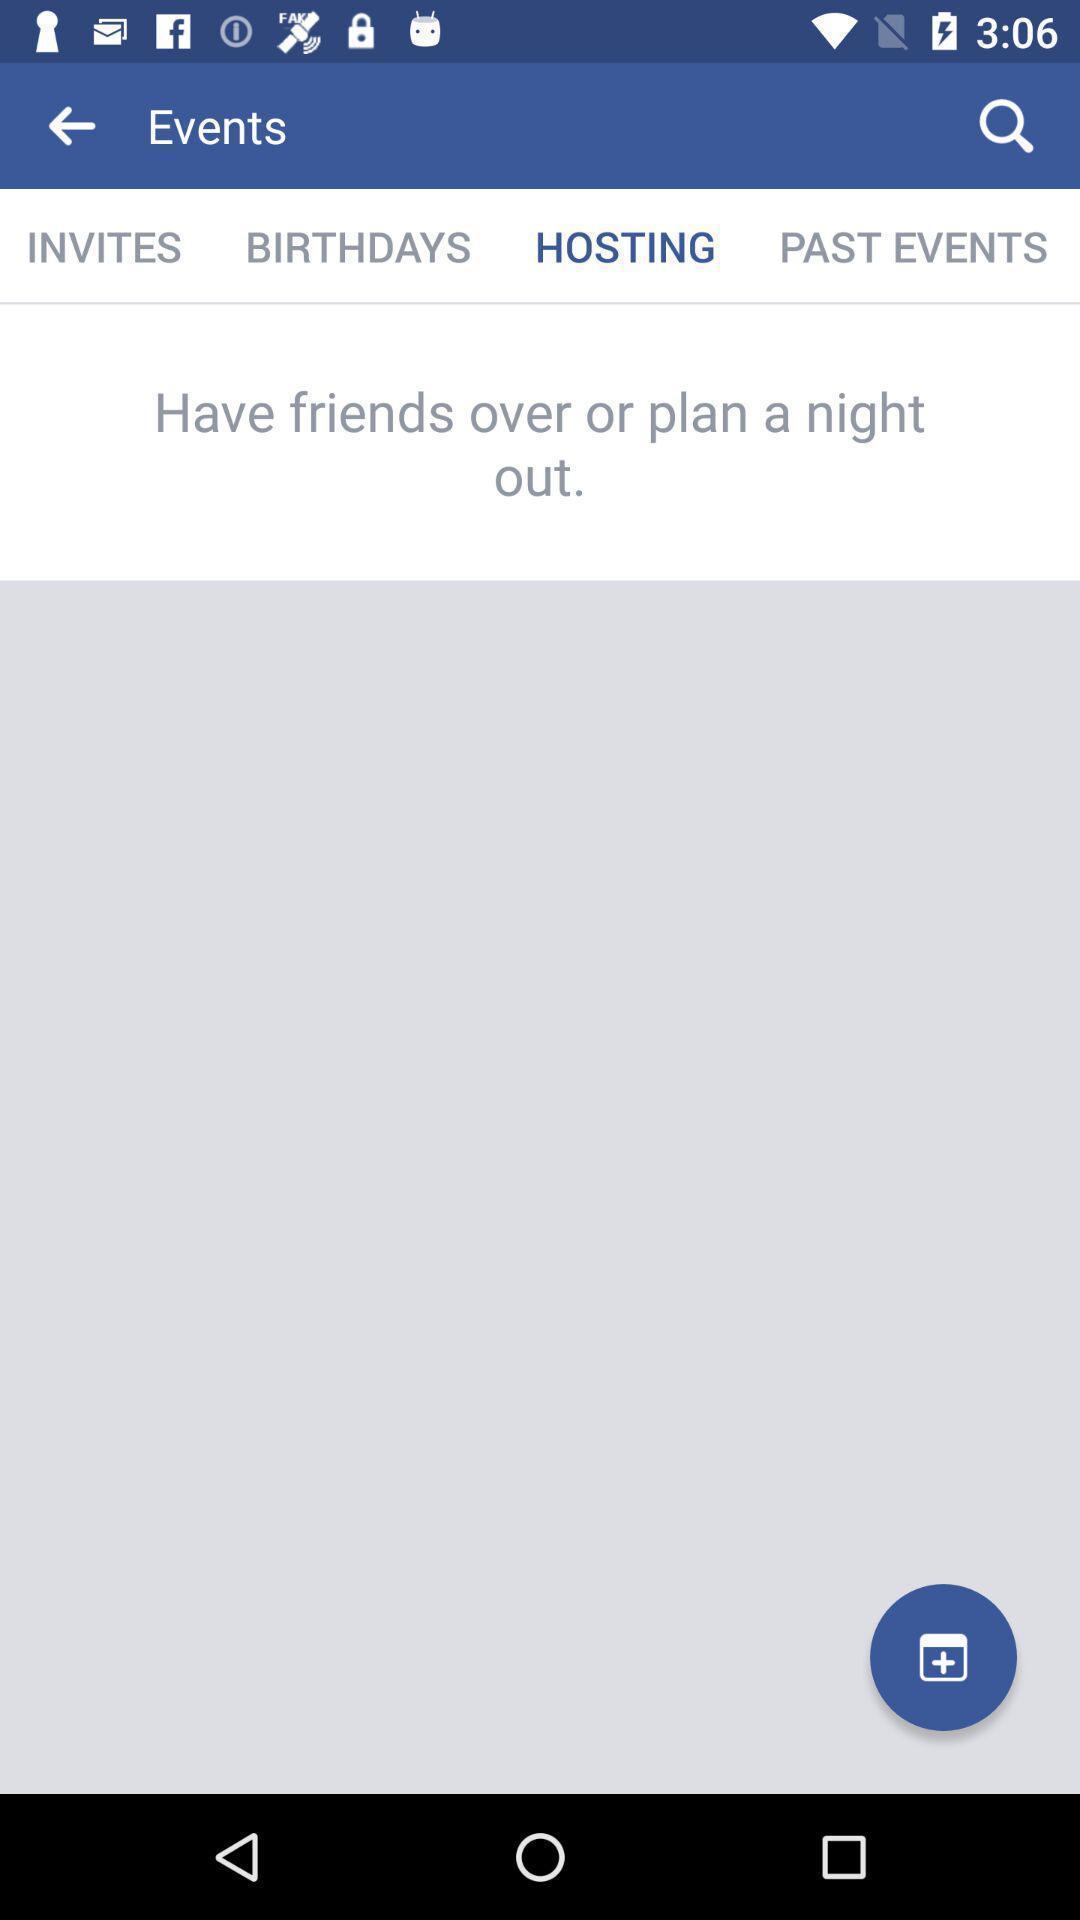What details can you identify in this image? Page showing events with hosting. 